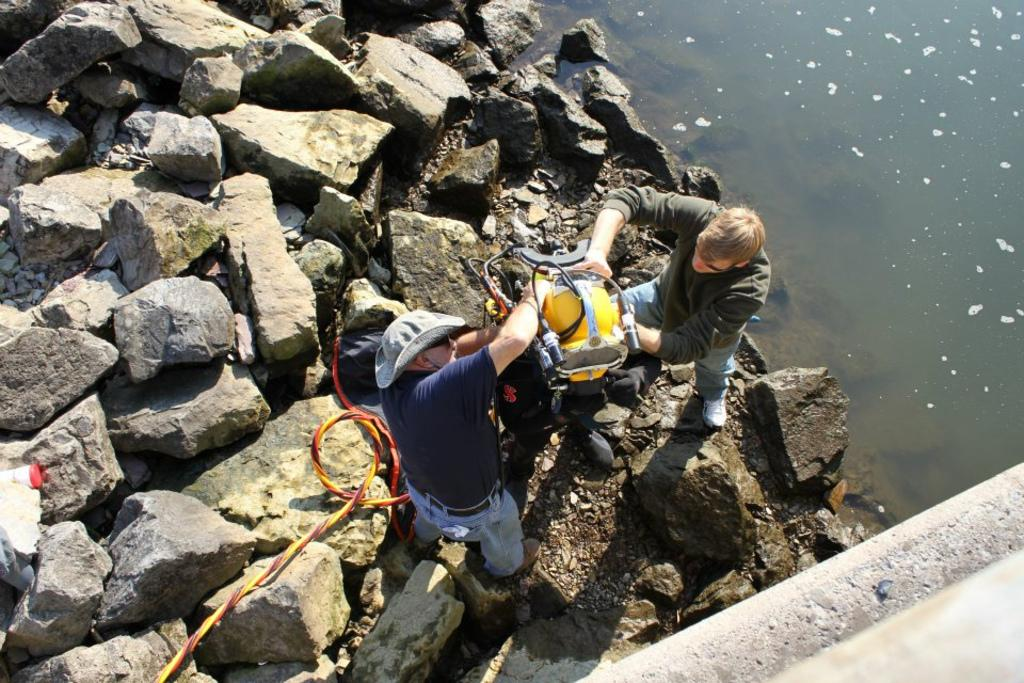How many people are in the image? There are two persons in the image. What is the terrain like where the persons are standing? The persons are standing on land with rocks. What are the persons holding in their hands? The persons are holding a machine in their hands. What can be seen on the right side of the image? There is water visible on the right side of the image. What is located at the right bottom of the image? There is a wall at the right bottom of the image. What type of pain is the person on the left experiencing in the image? There is no indication of pain or discomfort in the image; both persons appear to be standing normally. Can you see a quiver of arrows near the persons in the image? No, there is no quiver of arrows present in the image. 